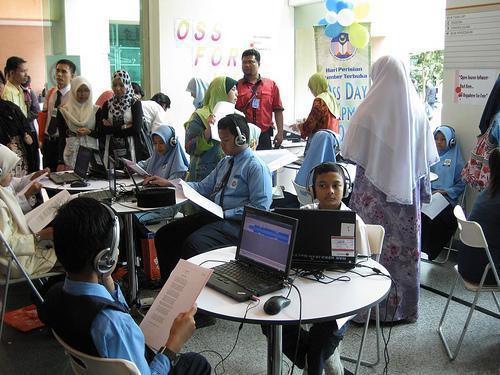How many pairs of headphones are being worn in this image?
Give a very brief answer. 8. 